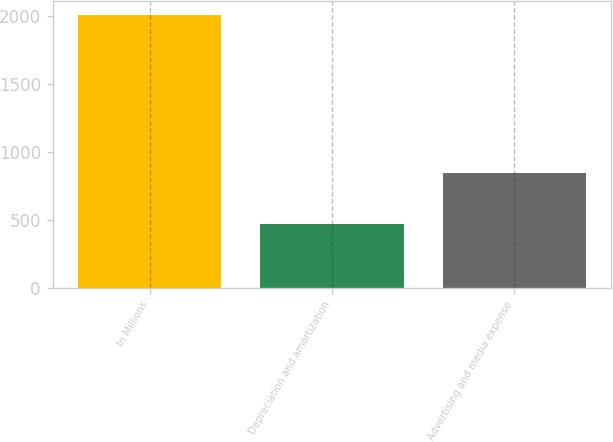Convert chart. <chart><loc_0><loc_0><loc_500><loc_500><bar_chart><fcel>In Millions<fcel>Depreciation and amortization<fcel>Advertising and media expense<nl><fcel>2011<fcel>472.6<fcel>843.7<nl></chart> 